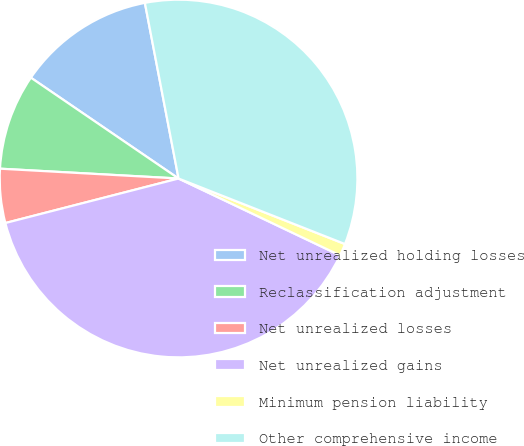Convert chart. <chart><loc_0><loc_0><loc_500><loc_500><pie_chart><fcel>Net unrealized holding losses<fcel>Reclassification adjustment<fcel>Net unrealized losses<fcel>Net unrealized gains<fcel>Minimum pension liability<fcel>Other comprehensive income<nl><fcel>12.45%<fcel>8.66%<fcel>4.88%<fcel>38.93%<fcel>1.1%<fcel>33.99%<nl></chart> 